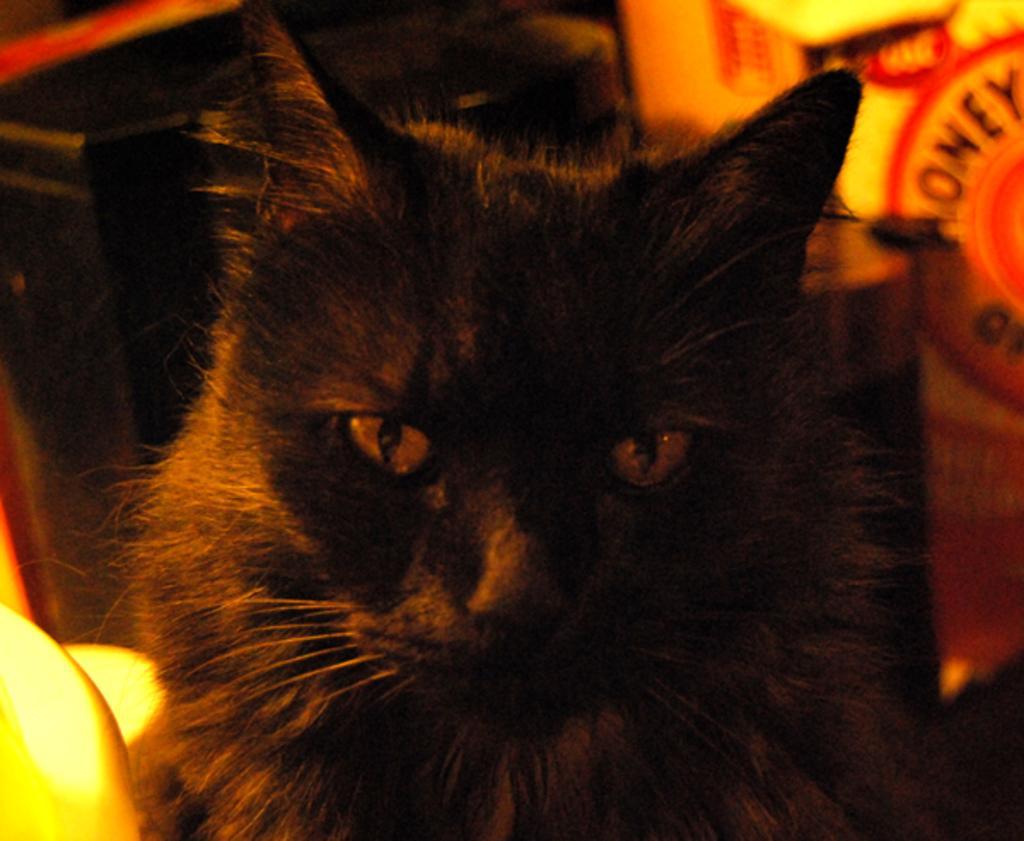In one or two sentences, can you explain what this image depicts? In the center of the image, we can see a cat and in the background, there are some objects and we can see some text. 